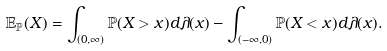<formula> <loc_0><loc_0><loc_500><loc_500>\mathbb { E } _ { \mathbb { P } } ( X ) = \int _ { ( 0 , \infty ) } \mathbb { P } ( X > x ) d \lambda ( x ) - \int _ { ( - \infty , 0 ) } \mathbb { P } ( X < x ) d \lambda ( x ) .</formula> 